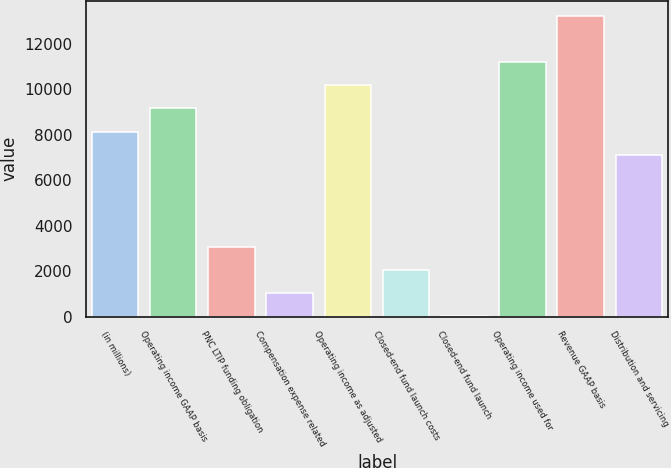Convert chart. <chart><loc_0><loc_0><loc_500><loc_500><bar_chart><fcel>(in millions)<fcel>Operating income GAAP basis<fcel>PNC LTIP funding obligation<fcel>Compensation expense related<fcel>Operating income as adjusted<fcel>Closed-end fund launch costs<fcel>Closed-end fund launch<fcel>Operating income used for<fcel>Revenue GAAP basis<fcel>Distribution and servicing<nl><fcel>8144.4<fcel>9162.2<fcel>3055.4<fcel>1019.8<fcel>10180<fcel>2037.6<fcel>2<fcel>11197.8<fcel>13233.4<fcel>7126.6<nl></chart> 